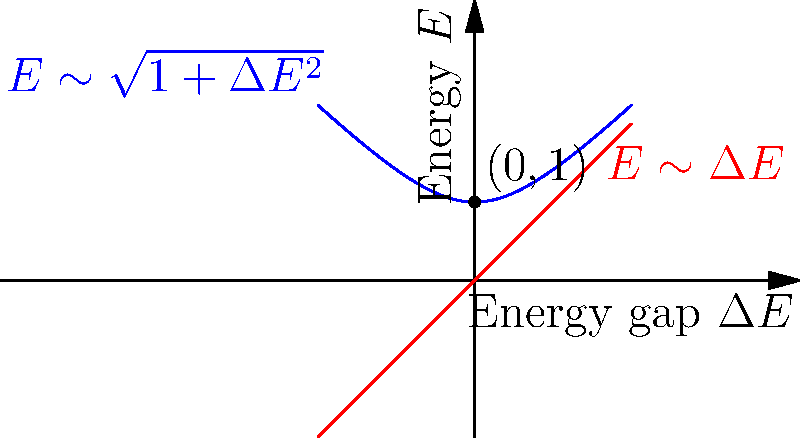Consider the energy spectrum of a quantum spin chain near a critical point, as shown in the graph. The blue curve represents the energy spectrum of the system, while the red line represents the linear approximation near the critical point. What is the dynamic critical exponent $z$ for this system, and what does it imply about the scaling of the energy gap $\Delta E$ with the correlation length $\xi$ near the critical point? To determine the dynamic critical exponent $z$ and understand its implications, let's follow these steps:

1) Near the critical point (0,1), we can approximate the energy spectrum (blue curve) by a power law:

   $$E \sim 1 + (\Delta E)^z$$

2) The red line represents the linear approximation near the critical point, which corresponds to $z = 1$:

   $$E \sim 1 + \Delta E$$

3) However, we can see that the blue curve deviates from this linear behavior. It actually follows a square root behavior near the critical point:

   $$E \sim \sqrt{1 + (\Delta E)^2}$$

4) Expanding this using the binomial theorem for small $\Delta E$:

   $$E \sim 1 + \frac{1}{2}(\Delta E)^2$$

5) Comparing this with the general form $E \sim 1 + (\Delta E)^z$, we can conclude that $z = 2$.

6) The dynamic critical exponent $z$ relates the correlation length $\xi$ to the energy gap $\Delta E$ near the critical point:

   $$\Delta E \sim \xi^{-z}$$

7) With $z = 2$, this relation becomes:

   $$\Delta E \sim \xi^{-2}$$

This implies that as the system approaches the critical point (i.e., as $\xi \to \infty$), the energy gap closes quadratically faster than it would for a system with $z = 1$.
Answer: $z = 2$, implying $\Delta E \sim \xi^{-2}$ 